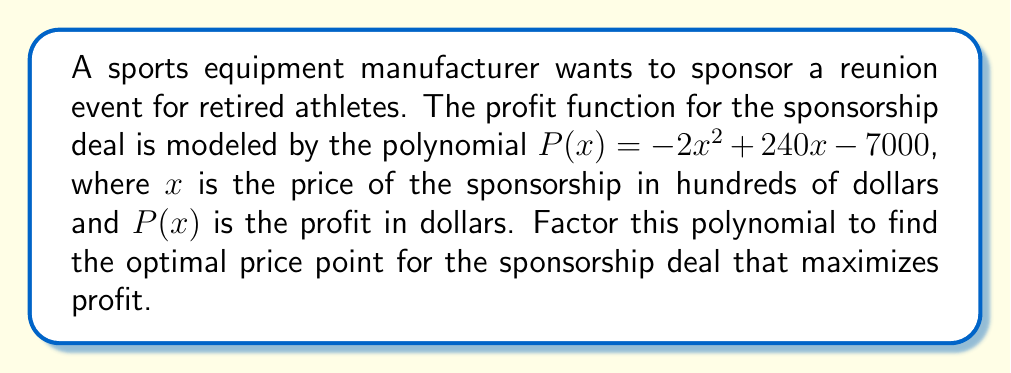Can you answer this question? To find the optimal price point, we need to factor the quadratic polynomial $P(x) = -2x^2 + 240x - 7000$ and find its vertex.

Step 1: Identify the coefficients
$a = -2$, $b = 240$, $c = -7000$

Step 2: Calculate $-b/(2a)$ to find the x-coordinate of the vertex
$x = -b/(2a) = -240/(-4) = 60$

Step 3: Factor the polynomial using the vertex form
$P(x) = a(x - h)^2 + k$, where $(h, k)$ is the vertex

$P(x) = -2(x - 60)^2 + k$

Step 4: Find $k$ by substituting $x = 60$ into the original equation
$P(60) = -2(60)^2 + 240(60) - 7000 = 7200$

So, $k = 7200$

Step 5: Write the factored form
$P(x) = -2(x - 60)^2 + 7200$

The vertex form shows that the maximum profit occurs at $x = 60$, which corresponds to a price of $6000 (60 * 100).
Answer: $P(x) = -2(x - 60)^2 + 7200$; Optimal price: $6000 